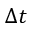Convert formula to latex. <formula><loc_0><loc_0><loc_500><loc_500>\Delta t</formula> 